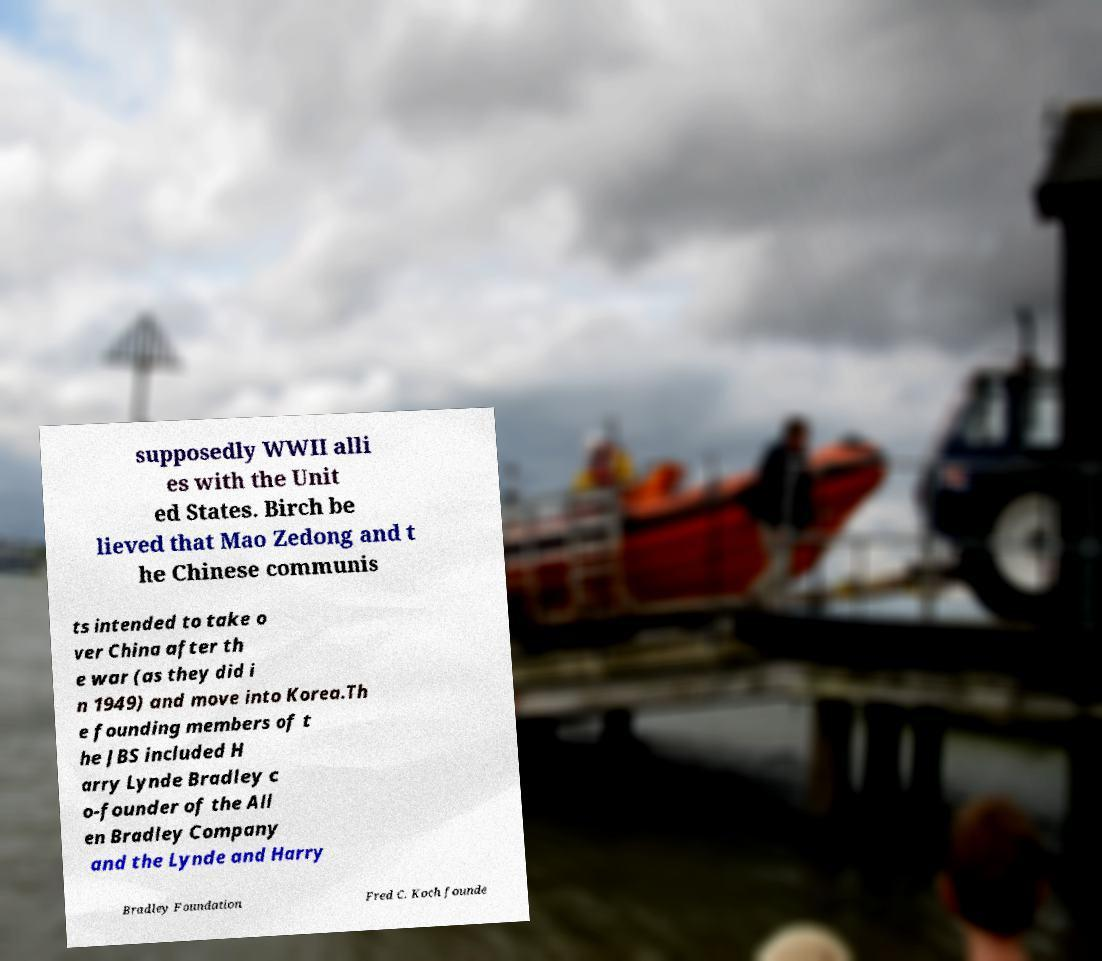Could you extract and type out the text from this image? supposedly WWII alli es with the Unit ed States. Birch be lieved that Mao Zedong and t he Chinese communis ts intended to take o ver China after th e war (as they did i n 1949) and move into Korea.Th e founding members of t he JBS included H arry Lynde Bradley c o-founder of the All en Bradley Company and the Lynde and Harry Bradley Foundation Fred C. Koch founde 